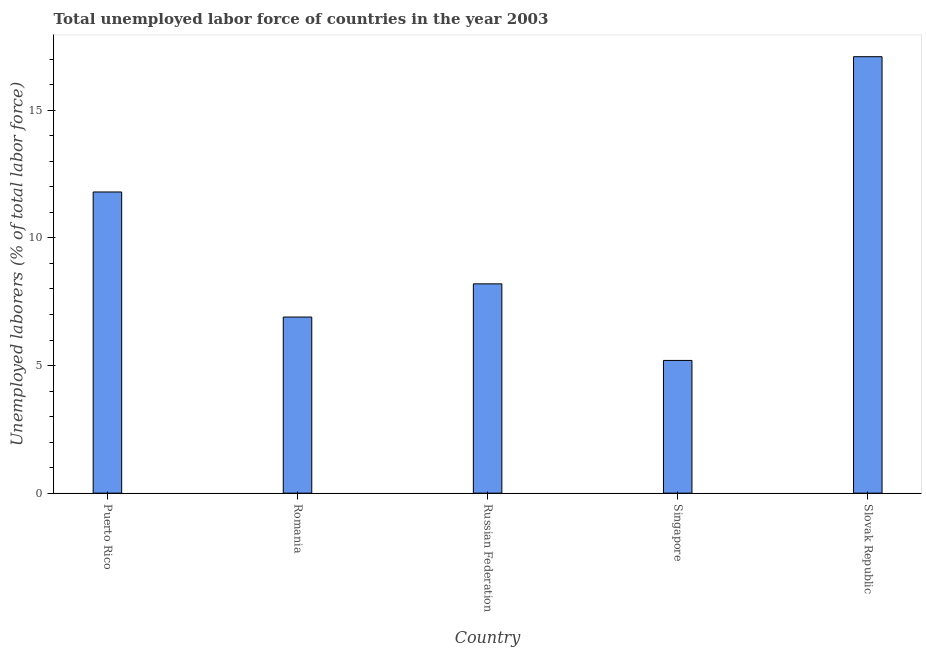Does the graph contain any zero values?
Offer a very short reply. No. What is the title of the graph?
Make the answer very short. Total unemployed labor force of countries in the year 2003. What is the label or title of the X-axis?
Make the answer very short. Country. What is the label or title of the Y-axis?
Provide a succinct answer. Unemployed laborers (% of total labor force). What is the total unemployed labour force in Puerto Rico?
Provide a succinct answer. 11.8. Across all countries, what is the maximum total unemployed labour force?
Your answer should be compact. 17.1. Across all countries, what is the minimum total unemployed labour force?
Ensure brevity in your answer.  5.2. In which country was the total unemployed labour force maximum?
Your response must be concise. Slovak Republic. In which country was the total unemployed labour force minimum?
Provide a short and direct response. Singapore. What is the sum of the total unemployed labour force?
Offer a terse response. 49.2. What is the difference between the total unemployed labour force in Russian Federation and Slovak Republic?
Offer a terse response. -8.9. What is the average total unemployed labour force per country?
Offer a very short reply. 9.84. What is the median total unemployed labour force?
Provide a succinct answer. 8.2. What is the ratio of the total unemployed labour force in Romania to that in Singapore?
Give a very brief answer. 1.33. Is the total unemployed labour force in Singapore less than that in Slovak Republic?
Offer a terse response. Yes. Is the sum of the total unemployed labour force in Puerto Rico and Slovak Republic greater than the maximum total unemployed labour force across all countries?
Your response must be concise. Yes. What is the difference between the highest and the lowest total unemployed labour force?
Offer a very short reply. 11.9. How many bars are there?
Offer a terse response. 5. Are all the bars in the graph horizontal?
Your answer should be very brief. No. Are the values on the major ticks of Y-axis written in scientific E-notation?
Your answer should be compact. No. What is the Unemployed laborers (% of total labor force) in Puerto Rico?
Your answer should be compact. 11.8. What is the Unemployed laborers (% of total labor force) in Romania?
Offer a very short reply. 6.9. What is the Unemployed laborers (% of total labor force) in Russian Federation?
Your response must be concise. 8.2. What is the Unemployed laborers (% of total labor force) in Singapore?
Offer a very short reply. 5.2. What is the Unemployed laborers (% of total labor force) in Slovak Republic?
Provide a short and direct response. 17.1. What is the difference between the Unemployed laborers (% of total labor force) in Puerto Rico and Russian Federation?
Provide a short and direct response. 3.6. What is the difference between the Unemployed laborers (% of total labor force) in Puerto Rico and Slovak Republic?
Ensure brevity in your answer.  -5.3. What is the difference between the Unemployed laborers (% of total labor force) in Romania and Russian Federation?
Keep it short and to the point. -1.3. What is the difference between the Unemployed laborers (% of total labor force) in Romania and Singapore?
Offer a very short reply. 1.7. What is the difference between the Unemployed laborers (% of total labor force) in Romania and Slovak Republic?
Provide a short and direct response. -10.2. What is the difference between the Unemployed laborers (% of total labor force) in Russian Federation and Slovak Republic?
Offer a terse response. -8.9. What is the ratio of the Unemployed laborers (% of total labor force) in Puerto Rico to that in Romania?
Provide a succinct answer. 1.71. What is the ratio of the Unemployed laborers (% of total labor force) in Puerto Rico to that in Russian Federation?
Offer a very short reply. 1.44. What is the ratio of the Unemployed laborers (% of total labor force) in Puerto Rico to that in Singapore?
Offer a very short reply. 2.27. What is the ratio of the Unemployed laborers (% of total labor force) in Puerto Rico to that in Slovak Republic?
Your answer should be compact. 0.69. What is the ratio of the Unemployed laborers (% of total labor force) in Romania to that in Russian Federation?
Keep it short and to the point. 0.84. What is the ratio of the Unemployed laborers (% of total labor force) in Romania to that in Singapore?
Your answer should be very brief. 1.33. What is the ratio of the Unemployed laborers (% of total labor force) in Romania to that in Slovak Republic?
Provide a succinct answer. 0.4. What is the ratio of the Unemployed laborers (% of total labor force) in Russian Federation to that in Singapore?
Give a very brief answer. 1.58. What is the ratio of the Unemployed laborers (% of total labor force) in Russian Federation to that in Slovak Republic?
Your answer should be very brief. 0.48. What is the ratio of the Unemployed laborers (% of total labor force) in Singapore to that in Slovak Republic?
Keep it short and to the point. 0.3. 